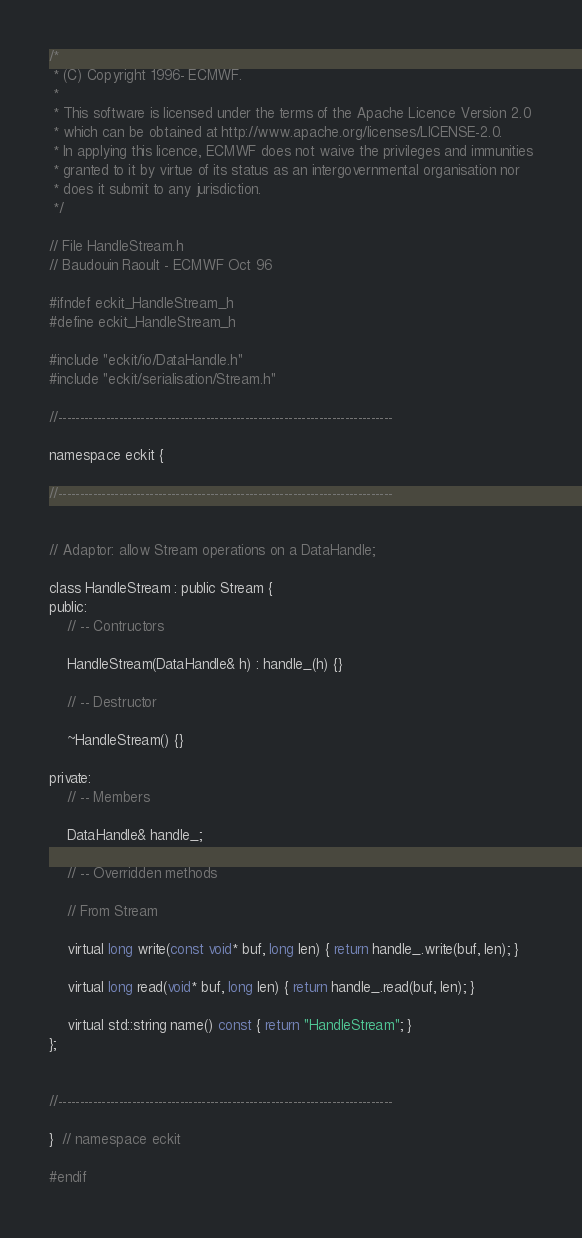Convert code to text. <code><loc_0><loc_0><loc_500><loc_500><_C_>/*
 * (C) Copyright 1996- ECMWF.
 *
 * This software is licensed under the terms of the Apache Licence Version 2.0
 * which can be obtained at http://www.apache.org/licenses/LICENSE-2.0.
 * In applying this licence, ECMWF does not waive the privileges and immunities
 * granted to it by virtue of its status as an intergovernmental organisation nor
 * does it submit to any jurisdiction.
 */

// File HandleStream.h
// Baudouin Raoult - ECMWF Oct 96

#ifndef eckit_HandleStream_h
#define eckit_HandleStream_h

#include "eckit/io/DataHandle.h"
#include "eckit/serialisation/Stream.h"

//-----------------------------------------------------------------------------

namespace eckit {

//-----------------------------------------------------------------------------


// Adaptor: allow Stream operations on a DataHandle;

class HandleStream : public Stream {
public:
    // -- Contructors

    HandleStream(DataHandle& h) : handle_(h) {}

    // -- Destructor

    ~HandleStream() {}

private:
    // -- Members

    DataHandle& handle_;

    // -- Overridden methods

    // From Stream

    virtual long write(const void* buf, long len) { return handle_.write(buf, len); }

    virtual long read(void* buf, long len) { return handle_.read(buf, len); }

    virtual std::string name() const { return "HandleStream"; }
};


//-----------------------------------------------------------------------------

}  // namespace eckit

#endif
</code> 